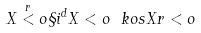<formula> <loc_0><loc_0><loc_500><loc_500>X \stackrel { r } < o \S i ^ { d } X < o \ k o s X r < o</formula> 